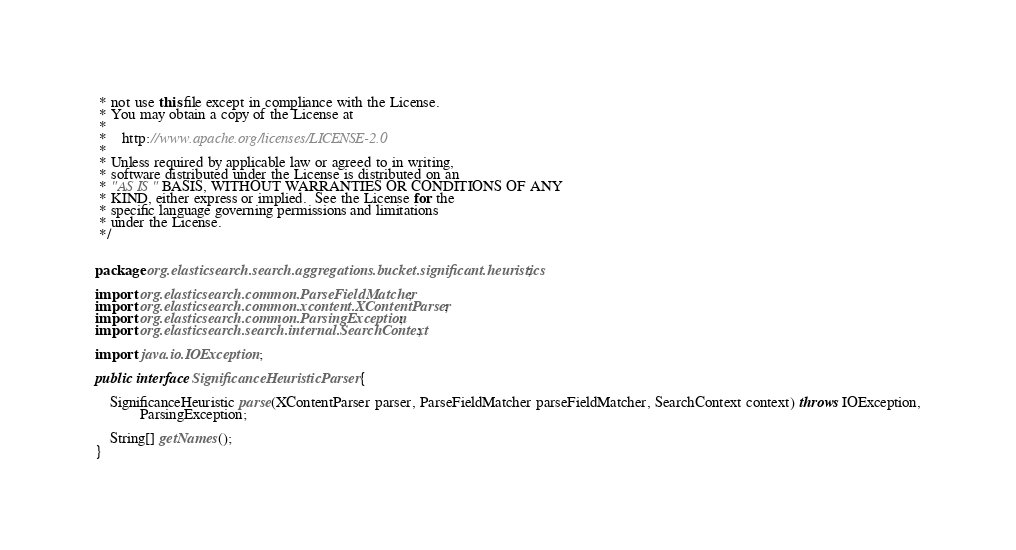<code> <loc_0><loc_0><loc_500><loc_500><_Java_> * not use this file except in compliance with the License.
 * You may obtain a copy of the License at
 *
 *    http://www.apache.org/licenses/LICENSE-2.0
 *
 * Unless required by applicable law or agreed to in writing,
 * software distributed under the License is distributed on an
 * "AS IS" BASIS, WITHOUT WARRANTIES OR CONDITIONS OF ANY
 * KIND, either express or implied.  See the License for the
 * specific language governing permissions and limitations
 * under the License.
 */


package org.elasticsearch.search.aggregations.bucket.significant.heuristics;

import org.elasticsearch.common.ParseFieldMatcher;
import org.elasticsearch.common.xcontent.XContentParser;
import org.elasticsearch.common.ParsingException;
import org.elasticsearch.search.internal.SearchContext;

import java.io.IOException;

public interface SignificanceHeuristicParser {

    SignificanceHeuristic parse(XContentParser parser, ParseFieldMatcher parseFieldMatcher, SearchContext context) throws IOException,
            ParsingException;

    String[] getNames();
}
</code> 